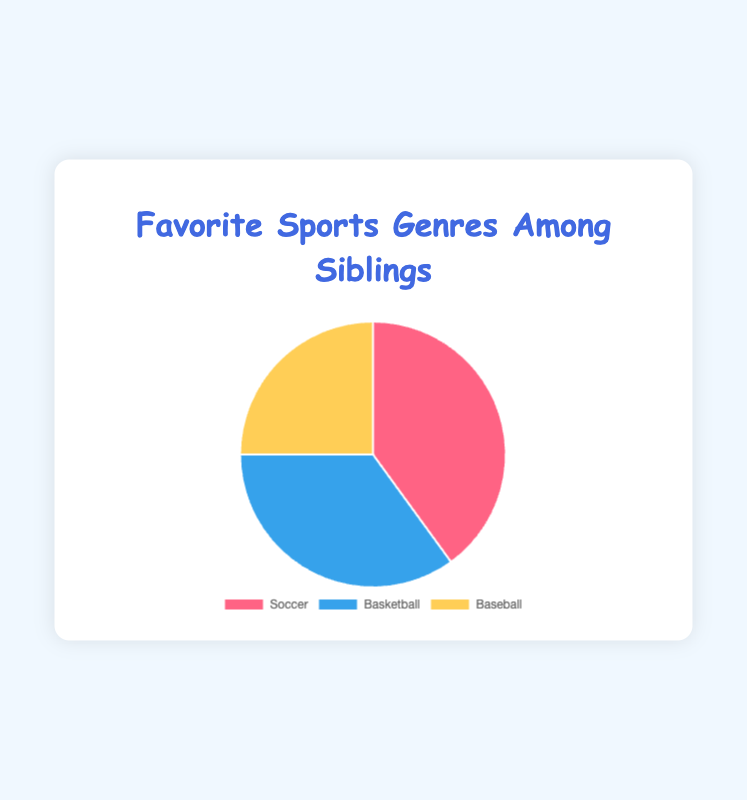Which sport is the most favored among siblings? Soccer has the highest percentage of preference at 40%, as indicated by the data.
Answer: Soccer Which sport has the smallest segment in the pie chart? Baseball has the smallest segment with 25%, making it the least favored.
Answer: Baseball How many more percentage points prefer Soccer compared to Baseball? Soccer is preferred by 40% and Baseball by 25%. The difference is 40 - 25 = 15 percentage points.
Answer: 15 Which two sports together make up more than half of the siblings' preferences? Soccer and Basketball together make up 40% + 35% = 75%, which is more than half.
Answer: Soccer and Basketball If we combine the preferences for Basketball and Baseball, what is their total percentage? The combined total is 35% (Basketball) + 25% (Baseball) = 60%.
Answer: 60% What color represents Basketball in the pie chart? Basketball is represented by the color blue, as indicated by the description of the data.
Answer: Blue By how many percentage points does the least favored sport fall short of the most favored sport? The most favored sport, Soccer, is 40%, and the least favored, Baseball, is 25%. The difference is 40 - 25 = 15 percentage points.
Answer: 15 Which sport preference comes closest to the middle value (i.e., median) of the given percentages? The percentages are 40% (Soccer), 35% (Basketball), and 25% (Baseball). The middle value (median) is 35%, which corresponds to Basketball.
Answer: Basketball 